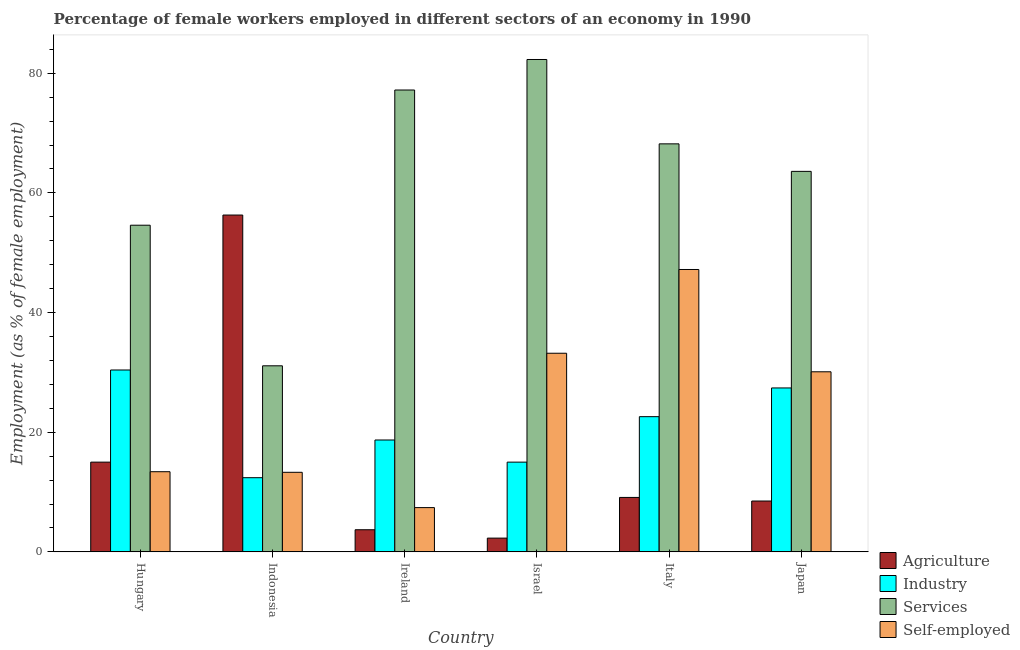How many different coloured bars are there?
Keep it short and to the point. 4. How many groups of bars are there?
Keep it short and to the point. 6. Are the number of bars per tick equal to the number of legend labels?
Your answer should be very brief. Yes. What is the label of the 1st group of bars from the left?
Offer a terse response. Hungary. In how many cases, is the number of bars for a given country not equal to the number of legend labels?
Your answer should be very brief. 0. Across all countries, what is the maximum percentage of female workers in agriculture?
Offer a terse response. 56.3. Across all countries, what is the minimum percentage of self employed female workers?
Make the answer very short. 7.4. In which country was the percentage of self employed female workers minimum?
Your answer should be compact. Ireland. What is the total percentage of female workers in industry in the graph?
Offer a terse response. 126.5. What is the difference between the percentage of female workers in agriculture in Israel and that in Japan?
Your answer should be very brief. -6.2. What is the difference between the percentage of female workers in agriculture in Israel and the percentage of female workers in industry in Indonesia?
Provide a succinct answer. -10.1. What is the average percentage of female workers in agriculture per country?
Your answer should be compact. 15.82. What is the difference between the percentage of female workers in industry and percentage of female workers in agriculture in Ireland?
Your answer should be very brief. 15. What is the ratio of the percentage of female workers in agriculture in Ireland to that in Italy?
Ensure brevity in your answer.  0.41. Is the percentage of female workers in agriculture in Hungary less than that in Israel?
Offer a very short reply. No. What is the difference between the highest and the second highest percentage of female workers in agriculture?
Your answer should be very brief. 41.3. What is the difference between the highest and the lowest percentage of female workers in agriculture?
Give a very brief answer. 54. In how many countries, is the percentage of female workers in agriculture greater than the average percentage of female workers in agriculture taken over all countries?
Provide a succinct answer. 1. Is it the case that in every country, the sum of the percentage of female workers in services and percentage of female workers in agriculture is greater than the sum of percentage of female workers in industry and percentage of self employed female workers?
Provide a succinct answer. No. What does the 4th bar from the left in Italy represents?
Your response must be concise. Self-employed. What does the 4th bar from the right in Japan represents?
Your answer should be very brief. Agriculture. Is it the case that in every country, the sum of the percentage of female workers in agriculture and percentage of female workers in industry is greater than the percentage of female workers in services?
Provide a succinct answer. No. Are all the bars in the graph horizontal?
Keep it short and to the point. No. Are the values on the major ticks of Y-axis written in scientific E-notation?
Ensure brevity in your answer.  No. Does the graph contain any zero values?
Offer a terse response. No. Does the graph contain grids?
Make the answer very short. No. How are the legend labels stacked?
Your answer should be compact. Vertical. What is the title of the graph?
Provide a short and direct response. Percentage of female workers employed in different sectors of an economy in 1990. What is the label or title of the Y-axis?
Offer a terse response. Employment (as % of female employment). What is the Employment (as % of female employment) of Industry in Hungary?
Provide a short and direct response. 30.4. What is the Employment (as % of female employment) of Services in Hungary?
Offer a terse response. 54.6. What is the Employment (as % of female employment) of Self-employed in Hungary?
Keep it short and to the point. 13.4. What is the Employment (as % of female employment) in Agriculture in Indonesia?
Keep it short and to the point. 56.3. What is the Employment (as % of female employment) in Industry in Indonesia?
Your response must be concise. 12.4. What is the Employment (as % of female employment) of Services in Indonesia?
Your response must be concise. 31.1. What is the Employment (as % of female employment) of Self-employed in Indonesia?
Provide a short and direct response. 13.3. What is the Employment (as % of female employment) in Agriculture in Ireland?
Ensure brevity in your answer.  3.7. What is the Employment (as % of female employment) in Industry in Ireland?
Your response must be concise. 18.7. What is the Employment (as % of female employment) of Services in Ireland?
Offer a terse response. 77.2. What is the Employment (as % of female employment) in Self-employed in Ireland?
Your response must be concise. 7.4. What is the Employment (as % of female employment) of Agriculture in Israel?
Offer a very short reply. 2.3. What is the Employment (as % of female employment) of Industry in Israel?
Keep it short and to the point. 15. What is the Employment (as % of female employment) of Services in Israel?
Your answer should be compact. 82.3. What is the Employment (as % of female employment) of Self-employed in Israel?
Offer a terse response. 33.2. What is the Employment (as % of female employment) of Agriculture in Italy?
Offer a terse response. 9.1. What is the Employment (as % of female employment) in Industry in Italy?
Provide a short and direct response. 22.6. What is the Employment (as % of female employment) of Services in Italy?
Your response must be concise. 68.2. What is the Employment (as % of female employment) of Self-employed in Italy?
Ensure brevity in your answer.  47.2. What is the Employment (as % of female employment) in Industry in Japan?
Offer a very short reply. 27.4. What is the Employment (as % of female employment) of Services in Japan?
Provide a succinct answer. 63.6. What is the Employment (as % of female employment) in Self-employed in Japan?
Provide a short and direct response. 30.1. Across all countries, what is the maximum Employment (as % of female employment) in Agriculture?
Give a very brief answer. 56.3. Across all countries, what is the maximum Employment (as % of female employment) of Industry?
Provide a short and direct response. 30.4. Across all countries, what is the maximum Employment (as % of female employment) in Services?
Keep it short and to the point. 82.3. Across all countries, what is the maximum Employment (as % of female employment) of Self-employed?
Provide a succinct answer. 47.2. Across all countries, what is the minimum Employment (as % of female employment) in Agriculture?
Provide a succinct answer. 2.3. Across all countries, what is the minimum Employment (as % of female employment) in Industry?
Offer a very short reply. 12.4. Across all countries, what is the minimum Employment (as % of female employment) in Services?
Make the answer very short. 31.1. Across all countries, what is the minimum Employment (as % of female employment) of Self-employed?
Make the answer very short. 7.4. What is the total Employment (as % of female employment) of Agriculture in the graph?
Provide a succinct answer. 94.9. What is the total Employment (as % of female employment) in Industry in the graph?
Offer a very short reply. 126.5. What is the total Employment (as % of female employment) in Services in the graph?
Give a very brief answer. 377. What is the total Employment (as % of female employment) in Self-employed in the graph?
Give a very brief answer. 144.6. What is the difference between the Employment (as % of female employment) of Agriculture in Hungary and that in Indonesia?
Keep it short and to the point. -41.3. What is the difference between the Employment (as % of female employment) of Industry in Hungary and that in Indonesia?
Your answer should be very brief. 18. What is the difference between the Employment (as % of female employment) in Services in Hungary and that in Indonesia?
Ensure brevity in your answer.  23.5. What is the difference between the Employment (as % of female employment) of Self-employed in Hungary and that in Indonesia?
Keep it short and to the point. 0.1. What is the difference between the Employment (as % of female employment) in Industry in Hungary and that in Ireland?
Your answer should be compact. 11.7. What is the difference between the Employment (as % of female employment) in Services in Hungary and that in Ireland?
Ensure brevity in your answer.  -22.6. What is the difference between the Employment (as % of female employment) of Self-employed in Hungary and that in Ireland?
Give a very brief answer. 6. What is the difference between the Employment (as % of female employment) of Industry in Hungary and that in Israel?
Provide a succinct answer. 15.4. What is the difference between the Employment (as % of female employment) of Services in Hungary and that in Israel?
Offer a terse response. -27.7. What is the difference between the Employment (as % of female employment) in Self-employed in Hungary and that in Israel?
Provide a short and direct response. -19.8. What is the difference between the Employment (as % of female employment) of Agriculture in Hungary and that in Italy?
Offer a terse response. 5.9. What is the difference between the Employment (as % of female employment) in Industry in Hungary and that in Italy?
Make the answer very short. 7.8. What is the difference between the Employment (as % of female employment) in Services in Hungary and that in Italy?
Your response must be concise. -13.6. What is the difference between the Employment (as % of female employment) of Self-employed in Hungary and that in Italy?
Make the answer very short. -33.8. What is the difference between the Employment (as % of female employment) in Agriculture in Hungary and that in Japan?
Provide a succinct answer. 6.5. What is the difference between the Employment (as % of female employment) of Industry in Hungary and that in Japan?
Give a very brief answer. 3. What is the difference between the Employment (as % of female employment) in Services in Hungary and that in Japan?
Provide a short and direct response. -9. What is the difference between the Employment (as % of female employment) in Self-employed in Hungary and that in Japan?
Offer a terse response. -16.7. What is the difference between the Employment (as % of female employment) of Agriculture in Indonesia and that in Ireland?
Offer a very short reply. 52.6. What is the difference between the Employment (as % of female employment) of Industry in Indonesia and that in Ireland?
Give a very brief answer. -6.3. What is the difference between the Employment (as % of female employment) in Services in Indonesia and that in Ireland?
Offer a terse response. -46.1. What is the difference between the Employment (as % of female employment) in Self-employed in Indonesia and that in Ireland?
Give a very brief answer. 5.9. What is the difference between the Employment (as % of female employment) in Services in Indonesia and that in Israel?
Provide a short and direct response. -51.2. What is the difference between the Employment (as % of female employment) of Self-employed in Indonesia and that in Israel?
Ensure brevity in your answer.  -19.9. What is the difference between the Employment (as % of female employment) of Agriculture in Indonesia and that in Italy?
Keep it short and to the point. 47.2. What is the difference between the Employment (as % of female employment) in Services in Indonesia and that in Italy?
Keep it short and to the point. -37.1. What is the difference between the Employment (as % of female employment) of Self-employed in Indonesia and that in Italy?
Your answer should be very brief. -33.9. What is the difference between the Employment (as % of female employment) in Agriculture in Indonesia and that in Japan?
Offer a terse response. 47.8. What is the difference between the Employment (as % of female employment) of Industry in Indonesia and that in Japan?
Provide a short and direct response. -15. What is the difference between the Employment (as % of female employment) of Services in Indonesia and that in Japan?
Provide a short and direct response. -32.5. What is the difference between the Employment (as % of female employment) of Self-employed in Indonesia and that in Japan?
Your response must be concise. -16.8. What is the difference between the Employment (as % of female employment) of Industry in Ireland and that in Israel?
Make the answer very short. 3.7. What is the difference between the Employment (as % of female employment) of Services in Ireland and that in Israel?
Provide a short and direct response. -5.1. What is the difference between the Employment (as % of female employment) in Self-employed in Ireland and that in Israel?
Keep it short and to the point. -25.8. What is the difference between the Employment (as % of female employment) in Industry in Ireland and that in Italy?
Give a very brief answer. -3.9. What is the difference between the Employment (as % of female employment) in Self-employed in Ireland and that in Italy?
Offer a very short reply. -39.8. What is the difference between the Employment (as % of female employment) in Services in Ireland and that in Japan?
Provide a short and direct response. 13.6. What is the difference between the Employment (as % of female employment) of Self-employed in Ireland and that in Japan?
Your response must be concise. -22.7. What is the difference between the Employment (as % of female employment) in Industry in Israel and that in Italy?
Offer a very short reply. -7.6. What is the difference between the Employment (as % of female employment) of Services in Israel and that in Italy?
Keep it short and to the point. 14.1. What is the difference between the Employment (as % of female employment) in Agriculture in Israel and that in Japan?
Your answer should be very brief. -6.2. What is the difference between the Employment (as % of female employment) in Self-employed in Israel and that in Japan?
Keep it short and to the point. 3.1. What is the difference between the Employment (as % of female employment) of Agriculture in Italy and that in Japan?
Provide a short and direct response. 0.6. What is the difference between the Employment (as % of female employment) of Services in Italy and that in Japan?
Your answer should be very brief. 4.6. What is the difference between the Employment (as % of female employment) in Agriculture in Hungary and the Employment (as % of female employment) in Industry in Indonesia?
Provide a succinct answer. 2.6. What is the difference between the Employment (as % of female employment) in Agriculture in Hungary and the Employment (as % of female employment) in Services in Indonesia?
Provide a short and direct response. -16.1. What is the difference between the Employment (as % of female employment) of Industry in Hungary and the Employment (as % of female employment) of Services in Indonesia?
Offer a terse response. -0.7. What is the difference between the Employment (as % of female employment) in Services in Hungary and the Employment (as % of female employment) in Self-employed in Indonesia?
Offer a terse response. 41.3. What is the difference between the Employment (as % of female employment) in Agriculture in Hungary and the Employment (as % of female employment) in Services in Ireland?
Provide a succinct answer. -62.2. What is the difference between the Employment (as % of female employment) of Industry in Hungary and the Employment (as % of female employment) of Services in Ireland?
Offer a terse response. -46.8. What is the difference between the Employment (as % of female employment) of Industry in Hungary and the Employment (as % of female employment) of Self-employed in Ireland?
Your response must be concise. 23. What is the difference between the Employment (as % of female employment) of Services in Hungary and the Employment (as % of female employment) of Self-employed in Ireland?
Offer a terse response. 47.2. What is the difference between the Employment (as % of female employment) of Agriculture in Hungary and the Employment (as % of female employment) of Industry in Israel?
Offer a terse response. 0. What is the difference between the Employment (as % of female employment) in Agriculture in Hungary and the Employment (as % of female employment) in Services in Israel?
Your answer should be compact. -67.3. What is the difference between the Employment (as % of female employment) in Agriculture in Hungary and the Employment (as % of female employment) in Self-employed in Israel?
Your answer should be very brief. -18.2. What is the difference between the Employment (as % of female employment) in Industry in Hungary and the Employment (as % of female employment) in Services in Israel?
Make the answer very short. -51.9. What is the difference between the Employment (as % of female employment) in Services in Hungary and the Employment (as % of female employment) in Self-employed in Israel?
Ensure brevity in your answer.  21.4. What is the difference between the Employment (as % of female employment) in Agriculture in Hungary and the Employment (as % of female employment) in Industry in Italy?
Provide a succinct answer. -7.6. What is the difference between the Employment (as % of female employment) of Agriculture in Hungary and the Employment (as % of female employment) of Services in Italy?
Offer a terse response. -53.2. What is the difference between the Employment (as % of female employment) in Agriculture in Hungary and the Employment (as % of female employment) in Self-employed in Italy?
Your answer should be very brief. -32.2. What is the difference between the Employment (as % of female employment) of Industry in Hungary and the Employment (as % of female employment) of Services in Italy?
Make the answer very short. -37.8. What is the difference between the Employment (as % of female employment) in Industry in Hungary and the Employment (as % of female employment) in Self-employed in Italy?
Your response must be concise. -16.8. What is the difference between the Employment (as % of female employment) in Agriculture in Hungary and the Employment (as % of female employment) in Services in Japan?
Give a very brief answer. -48.6. What is the difference between the Employment (as % of female employment) of Agriculture in Hungary and the Employment (as % of female employment) of Self-employed in Japan?
Ensure brevity in your answer.  -15.1. What is the difference between the Employment (as % of female employment) in Industry in Hungary and the Employment (as % of female employment) in Services in Japan?
Provide a succinct answer. -33.2. What is the difference between the Employment (as % of female employment) of Services in Hungary and the Employment (as % of female employment) of Self-employed in Japan?
Provide a short and direct response. 24.5. What is the difference between the Employment (as % of female employment) of Agriculture in Indonesia and the Employment (as % of female employment) of Industry in Ireland?
Make the answer very short. 37.6. What is the difference between the Employment (as % of female employment) of Agriculture in Indonesia and the Employment (as % of female employment) of Services in Ireland?
Provide a succinct answer. -20.9. What is the difference between the Employment (as % of female employment) of Agriculture in Indonesia and the Employment (as % of female employment) of Self-employed in Ireland?
Offer a very short reply. 48.9. What is the difference between the Employment (as % of female employment) of Industry in Indonesia and the Employment (as % of female employment) of Services in Ireland?
Provide a succinct answer. -64.8. What is the difference between the Employment (as % of female employment) of Industry in Indonesia and the Employment (as % of female employment) of Self-employed in Ireland?
Offer a very short reply. 5. What is the difference between the Employment (as % of female employment) in Services in Indonesia and the Employment (as % of female employment) in Self-employed in Ireland?
Keep it short and to the point. 23.7. What is the difference between the Employment (as % of female employment) of Agriculture in Indonesia and the Employment (as % of female employment) of Industry in Israel?
Ensure brevity in your answer.  41.3. What is the difference between the Employment (as % of female employment) in Agriculture in Indonesia and the Employment (as % of female employment) in Services in Israel?
Keep it short and to the point. -26. What is the difference between the Employment (as % of female employment) of Agriculture in Indonesia and the Employment (as % of female employment) of Self-employed in Israel?
Make the answer very short. 23.1. What is the difference between the Employment (as % of female employment) in Industry in Indonesia and the Employment (as % of female employment) in Services in Israel?
Make the answer very short. -69.9. What is the difference between the Employment (as % of female employment) of Industry in Indonesia and the Employment (as % of female employment) of Self-employed in Israel?
Offer a terse response. -20.8. What is the difference between the Employment (as % of female employment) of Services in Indonesia and the Employment (as % of female employment) of Self-employed in Israel?
Offer a very short reply. -2.1. What is the difference between the Employment (as % of female employment) in Agriculture in Indonesia and the Employment (as % of female employment) in Industry in Italy?
Your answer should be very brief. 33.7. What is the difference between the Employment (as % of female employment) in Industry in Indonesia and the Employment (as % of female employment) in Services in Italy?
Make the answer very short. -55.8. What is the difference between the Employment (as % of female employment) in Industry in Indonesia and the Employment (as % of female employment) in Self-employed in Italy?
Your answer should be very brief. -34.8. What is the difference between the Employment (as % of female employment) of Services in Indonesia and the Employment (as % of female employment) of Self-employed in Italy?
Your answer should be compact. -16.1. What is the difference between the Employment (as % of female employment) in Agriculture in Indonesia and the Employment (as % of female employment) in Industry in Japan?
Provide a short and direct response. 28.9. What is the difference between the Employment (as % of female employment) of Agriculture in Indonesia and the Employment (as % of female employment) of Services in Japan?
Your answer should be very brief. -7.3. What is the difference between the Employment (as % of female employment) in Agriculture in Indonesia and the Employment (as % of female employment) in Self-employed in Japan?
Your answer should be very brief. 26.2. What is the difference between the Employment (as % of female employment) of Industry in Indonesia and the Employment (as % of female employment) of Services in Japan?
Offer a very short reply. -51.2. What is the difference between the Employment (as % of female employment) of Industry in Indonesia and the Employment (as % of female employment) of Self-employed in Japan?
Make the answer very short. -17.7. What is the difference between the Employment (as % of female employment) of Services in Indonesia and the Employment (as % of female employment) of Self-employed in Japan?
Make the answer very short. 1. What is the difference between the Employment (as % of female employment) in Agriculture in Ireland and the Employment (as % of female employment) in Industry in Israel?
Your answer should be very brief. -11.3. What is the difference between the Employment (as % of female employment) in Agriculture in Ireland and the Employment (as % of female employment) in Services in Israel?
Your answer should be compact. -78.6. What is the difference between the Employment (as % of female employment) of Agriculture in Ireland and the Employment (as % of female employment) of Self-employed in Israel?
Give a very brief answer. -29.5. What is the difference between the Employment (as % of female employment) of Industry in Ireland and the Employment (as % of female employment) of Services in Israel?
Give a very brief answer. -63.6. What is the difference between the Employment (as % of female employment) in Industry in Ireland and the Employment (as % of female employment) in Self-employed in Israel?
Make the answer very short. -14.5. What is the difference between the Employment (as % of female employment) of Agriculture in Ireland and the Employment (as % of female employment) of Industry in Italy?
Offer a terse response. -18.9. What is the difference between the Employment (as % of female employment) of Agriculture in Ireland and the Employment (as % of female employment) of Services in Italy?
Offer a terse response. -64.5. What is the difference between the Employment (as % of female employment) of Agriculture in Ireland and the Employment (as % of female employment) of Self-employed in Italy?
Provide a succinct answer. -43.5. What is the difference between the Employment (as % of female employment) of Industry in Ireland and the Employment (as % of female employment) of Services in Italy?
Your answer should be very brief. -49.5. What is the difference between the Employment (as % of female employment) of Industry in Ireland and the Employment (as % of female employment) of Self-employed in Italy?
Your answer should be very brief. -28.5. What is the difference between the Employment (as % of female employment) of Agriculture in Ireland and the Employment (as % of female employment) of Industry in Japan?
Your response must be concise. -23.7. What is the difference between the Employment (as % of female employment) of Agriculture in Ireland and the Employment (as % of female employment) of Services in Japan?
Offer a terse response. -59.9. What is the difference between the Employment (as % of female employment) in Agriculture in Ireland and the Employment (as % of female employment) in Self-employed in Japan?
Ensure brevity in your answer.  -26.4. What is the difference between the Employment (as % of female employment) of Industry in Ireland and the Employment (as % of female employment) of Services in Japan?
Keep it short and to the point. -44.9. What is the difference between the Employment (as % of female employment) in Services in Ireland and the Employment (as % of female employment) in Self-employed in Japan?
Provide a succinct answer. 47.1. What is the difference between the Employment (as % of female employment) in Agriculture in Israel and the Employment (as % of female employment) in Industry in Italy?
Your answer should be compact. -20.3. What is the difference between the Employment (as % of female employment) in Agriculture in Israel and the Employment (as % of female employment) in Services in Italy?
Provide a short and direct response. -65.9. What is the difference between the Employment (as % of female employment) in Agriculture in Israel and the Employment (as % of female employment) in Self-employed in Italy?
Ensure brevity in your answer.  -44.9. What is the difference between the Employment (as % of female employment) of Industry in Israel and the Employment (as % of female employment) of Services in Italy?
Give a very brief answer. -53.2. What is the difference between the Employment (as % of female employment) of Industry in Israel and the Employment (as % of female employment) of Self-employed in Italy?
Offer a terse response. -32.2. What is the difference between the Employment (as % of female employment) in Services in Israel and the Employment (as % of female employment) in Self-employed in Italy?
Provide a succinct answer. 35.1. What is the difference between the Employment (as % of female employment) in Agriculture in Israel and the Employment (as % of female employment) in Industry in Japan?
Offer a terse response. -25.1. What is the difference between the Employment (as % of female employment) in Agriculture in Israel and the Employment (as % of female employment) in Services in Japan?
Offer a terse response. -61.3. What is the difference between the Employment (as % of female employment) of Agriculture in Israel and the Employment (as % of female employment) of Self-employed in Japan?
Provide a short and direct response. -27.8. What is the difference between the Employment (as % of female employment) in Industry in Israel and the Employment (as % of female employment) in Services in Japan?
Offer a terse response. -48.6. What is the difference between the Employment (as % of female employment) of Industry in Israel and the Employment (as % of female employment) of Self-employed in Japan?
Your answer should be compact. -15.1. What is the difference between the Employment (as % of female employment) of Services in Israel and the Employment (as % of female employment) of Self-employed in Japan?
Ensure brevity in your answer.  52.2. What is the difference between the Employment (as % of female employment) in Agriculture in Italy and the Employment (as % of female employment) in Industry in Japan?
Give a very brief answer. -18.3. What is the difference between the Employment (as % of female employment) in Agriculture in Italy and the Employment (as % of female employment) in Services in Japan?
Make the answer very short. -54.5. What is the difference between the Employment (as % of female employment) in Agriculture in Italy and the Employment (as % of female employment) in Self-employed in Japan?
Offer a terse response. -21. What is the difference between the Employment (as % of female employment) of Industry in Italy and the Employment (as % of female employment) of Services in Japan?
Give a very brief answer. -41. What is the difference between the Employment (as % of female employment) in Services in Italy and the Employment (as % of female employment) in Self-employed in Japan?
Ensure brevity in your answer.  38.1. What is the average Employment (as % of female employment) in Agriculture per country?
Make the answer very short. 15.82. What is the average Employment (as % of female employment) in Industry per country?
Make the answer very short. 21.08. What is the average Employment (as % of female employment) of Services per country?
Provide a short and direct response. 62.83. What is the average Employment (as % of female employment) of Self-employed per country?
Offer a very short reply. 24.1. What is the difference between the Employment (as % of female employment) in Agriculture and Employment (as % of female employment) in Industry in Hungary?
Offer a terse response. -15.4. What is the difference between the Employment (as % of female employment) in Agriculture and Employment (as % of female employment) in Services in Hungary?
Your answer should be compact. -39.6. What is the difference between the Employment (as % of female employment) in Industry and Employment (as % of female employment) in Services in Hungary?
Provide a short and direct response. -24.2. What is the difference between the Employment (as % of female employment) of Industry and Employment (as % of female employment) of Self-employed in Hungary?
Ensure brevity in your answer.  17. What is the difference between the Employment (as % of female employment) in Services and Employment (as % of female employment) in Self-employed in Hungary?
Your response must be concise. 41.2. What is the difference between the Employment (as % of female employment) of Agriculture and Employment (as % of female employment) of Industry in Indonesia?
Your response must be concise. 43.9. What is the difference between the Employment (as % of female employment) in Agriculture and Employment (as % of female employment) in Services in Indonesia?
Make the answer very short. 25.2. What is the difference between the Employment (as % of female employment) of Industry and Employment (as % of female employment) of Services in Indonesia?
Give a very brief answer. -18.7. What is the difference between the Employment (as % of female employment) of Industry and Employment (as % of female employment) of Self-employed in Indonesia?
Your answer should be compact. -0.9. What is the difference between the Employment (as % of female employment) of Agriculture and Employment (as % of female employment) of Services in Ireland?
Offer a very short reply. -73.5. What is the difference between the Employment (as % of female employment) of Agriculture and Employment (as % of female employment) of Self-employed in Ireland?
Make the answer very short. -3.7. What is the difference between the Employment (as % of female employment) in Industry and Employment (as % of female employment) in Services in Ireland?
Make the answer very short. -58.5. What is the difference between the Employment (as % of female employment) of Services and Employment (as % of female employment) of Self-employed in Ireland?
Provide a short and direct response. 69.8. What is the difference between the Employment (as % of female employment) of Agriculture and Employment (as % of female employment) of Industry in Israel?
Offer a very short reply. -12.7. What is the difference between the Employment (as % of female employment) of Agriculture and Employment (as % of female employment) of Services in Israel?
Offer a terse response. -80. What is the difference between the Employment (as % of female employment) of Agriculture and Employment (as % of female employment) of Self-employed in Israel?
Your answer should be very brief. -30.9. What is the difference between the Employment (as % of female employment) in Industry and Employment (as % of female employment) in Services in Israel?
Offer a very short reply. -67.3. What is the difference between the Employment (as % of female employment) in Industry and Employment (as % of female employment) in Self-employed in Israel?
Ensure brevity in your answer.  -18.2. What is the difference between the Employment (as % of female employment) in Services and Employment (as % of female employment) in Self-employed in Israel?
Offer a terse response. 49.1. What is the difference between the Employment (as % of female employment) in Agriculture and Employment (as % of female employment) in Industry in Italy?
Ensure brevity in your answer.  -13.5. What is the difference between the Employment (as % of female employment) of Agriculture and Employment (as % of female employment) of Services in Italy?
Provide a succinct answer. -59.1. What is the difference between the Employment (as % of female employment) of Agriculture and Employment (as % of female employment) of Self-employed in Italy?
Offer a terse response. -38.1. What is the difference between the Employment (as % of female employment) of Industry and Employment (as % of female employment) of Services in Italy?
Your answer should be very brief. -45.6. What is the difference between the Employment (as % of female employment) of Industry and Employment (as % of female employment) of Self-employed in Italy?
Provide a succinct answer. -24.6. What is the difference between the Employment (as % of female employment) of Services and Employment (as % of female employment) of Self-employed in Italy?
Ensure brevity in your answer.  21. What is the difference between the Employment (as % of female employment) in Agriculture and Employment (as % of female employment) in Industry in Japan?
Give a very brief answer. -18.9. What is the difference between the Employment (as % of female employment) of Agriculture and Employment (as % of female employment) of Services in Japan?
Offer a very short reply. -55.1. What is the difference between the Employment (as % of female employment) in Agriculture and Employment (as % of female employment) in Self-employed in Japan?
Your answer should be very brief. -21.6. What is the difference between the Employment (as % of female employment) of Industry and Employment (as % of female employment) of Services in Japan?
Give a very brief answer. -36.2. What is the difference between the Employment (as % of female employment) of Industry and Employment (as % of female employment) of Self-employed in Japan?
Give a very brief answer. -2.7. What is the difference between the Employment (as % of female employment) of Services and Employment (as % of female employment) of Self-employed in Japan?
Make the answer very short. 33.5. What is the ratio of the Employment (as % of female employment) of Agriculture in Hungary to that in Indonesia?
Provide a short and direct response. 0.27. What is the ratio of the Employment (as % of female employment) in Industry in Hungary to that in Indonesia?
Keep it short and to the point. 2.45. What is the ratio of the Employment (as % of female employment) in Services in Hungary to that in Indonesia?
Your answer should be compact. 1.76. What is the ratio of the Employment (as % of female employment) in Self-employed in Hungary to that in Indonesia?
Your answer should be compact. 1.01. What is the ratio of the Employment (as % of female employment) of Agriculture in Hungary to that in Ireland?
Your response must be concise. 4.05. What is the ratio of the Employment (as % of female employment) in Industry in Hungary to that in Ireland?
Offer a terse response. 1.63. What is the ratio of the Employment (as % of female employment) of Services in Hungary to that in Ireland?
Provide a succinct answer. 0.71. What is the ratio of the Employment (as % of female employment) in Self-employed in Hungary to that in Ireland?
Your answer should be very brief. 1.81. What is the ratio of the Employment (as % of female employment) in Agriculture in Hungary to that in Israel?
Your answer should be compact. 6.52. What is the ratio of the Employment (as % of female employment) in Industry in Hungary to that in Israel?
Provide a succinct answer. 2.03. What is the ratio of the Employment (as % of female employment) in Services in Hungary to that in Israel?
Give a very brief answer. 0.66. What is the ratio of the Employment (as % of female employment) of Self-employed in Hungary to that in Israel?
Make the answer very short. 0.4. What is the ratio of the Employment (as % of female employment) in Agriculture in Hungary to that in Italy?
Offer a very short reply. 1.65. What is the ratio of the Employment (as % of female employment) of Industry in Hungary to that in Italy?
Provide a succinct answer. 1.35. What is the ratio of the Employment (as % of female employment) in Services in Hungary to that in Italy?
Offer a terse response. 0.8. What is the ratio of the Employment (as % of female employment) in Self-employed in Hungary to that in Italy?
Provide a succinct answer. 0.28. What is the ratio of the Employment (as % of female employment) of Agriculture in Hungary to that in Japan?
Offer a very short reply. 1.76. What is the ratio of the Employment (as % of female employment) in Industry in Hungary to that in Japan?
Your response must be concise. 1.11. What is the ratio of the Employment (as % of female employment) in Services in Hungary to that in Japan?
Offer a terse response. 0.86. What is the ratio of the Employment (as % of female employment) in Self-employed in Hungary to that in Japan?
Ensure brevity in your answer.  0.45. What is the ratio of the Employment (as % of female employment) of Agriculture in Indonesia to that in Ireland?
Provide a succinct answer. 15.22. What is the ratio of the Employment (as % of female employment) in Industry in Indonesia to that in Ireland?
Your answer should be very brief. 0.66. What is the ratio of the Employment (as % of female employment) in Services in Indonesia to that in Ireland?
Provide a succinct answer. 0.4. What is the ratio of the Employment (as % of female employment) of Self-employed in Indonesia to that in Ireland?
Provide a succinct answer. 1.8. What is the ratio of the Employment (as % of female employment) of Agriculture in Indonesia to that in Israel?
Offer a very short reply. 24.48. What is the ratio of the Employment (as % of female employment) in Industry in Indonesia to that in Israel?
Ensure brevity in your answer.  0.83. What is the ratio of the Employment (as % of female employment) of Services in Indonesia to that in Israel?
Make the answer very short. 0.38. What is the ratio of the Employment (as % of female employment) in Self-employed in Indonesia to that in Israel?
Offer a terse response. 0.4. What is the ratio of the Employment (as % of female employment) in Agriculture in Indonesia to that in Italy?
Offer a terse response. 6.19. What is the ratio of the Employment (as % of female employment) in Industry in Indonesia to that in Italy?
Offer a terse response. 0.55. What is the ratio of the Employment (as % of female employment) in Services in Indonesia to that in Italy?
Offer a terse response. 0.46. What is the ratio of the Employment (as % of female employment) in Self-employed in Indonesia to that in Italy?
Your answer should be very brief. 0.28. What is the ratio of the Employment (as % of female employment) in Agriculture in Indonesia to that in Japan?
Keep it short and to the point. 6.62. What is the ratio of the Employment (as % of female employment) in Industry in Indonesia to that in Japan?
Ensure brevity in your answer.  0.45. What is the ratio of the Employment (as % of female employment) in Services in Indonesia to that in Japan?
Offer a terse response. 0.49. What is the ratio of the Employment (as % of female employment) in Self-employed in Indonesia to that in Japan?
Offer a very short reply. 0.44. What is the ratio of the Employment (as % of female employment) in Agriculture in Ireland to that in Israel?
Your answer should be very brief. 1.61. What is the ratio of the Employment (as % of female employment) in Industry in Ireland to that in Israel?
Your answer should be compact. 1.25. What is the ratio of the Employment (as % of female employment) in Services in Ireland to that in Israel?
Make the answer very short. 0.94. What is the ratio of the Employment (as % of female employment) in Self-employed in Ireland to that in Israel?
Your answer should be compact. 0.22. What is the ratio of the Employment (as % of female employment) of Agriculture in Ireland to that in Italy?
Your answer should be very brief. 0.41. What is the ratio of the Employment (as % of female employment) in Industry in Ireland to that in Italy?
Your answer should be very brief. 0.83. What is the ratio of the Employment (as % of female employment) of Services in Ireland to that in Italy?
Make the answer very short. 1.13. What is the ratio of the Employment (as % of female employment) in Self-employed in Ireland to that in Italy?
Your response must be concise. 0.16. What is the ratio of the Employment (as % of female employment) in Agriculture in Ireland to that in Japan?
Offer a terse response. 0.44. What is the ratio of the Employment (as % of female employment) of Industry in Ireland to that in Japan?
Your answer should be compact. 0.68. What is the ratio of the Employment (as % of female employment) of Services in Ireland to that in Japan?
Provide a succinct answer. 1.21. What is the ratio of the Employment (as % of female employment) of Self-employed in Ireland to that in Japan?
Provide a short and direct response. 0.25. What is the ratio of the Employment (as % of female employment) of Agriculture in Israel to that in Italy?
Your answer should be very brief. 0.25. What is the ratio of the Employment (as % of female employment) in Industry in Israel to that in Italy?
Provide a succinct answer. 0.66. What is the ratio of the Employment (as % of female employment) in Services in Israel to that in Italy?
Offer a terse response. 1.21. What is the ratio of the Employment (as % of female employment) in Self-employed in Israel to that in Italy?
Your response must be concise. 0.7. What is the ratio of the Employment (as % of female employment) in Agriculture in Israel to that in Japan?
Provide a succinct answer. 0.27. What is the ratio of the Employment (as % of female employment) in Industry in Israel to that in Japan?
Ensure brevity in your answer.  0.55. What is the ratio of the Employment (as % of female employment) of Services in Israel to that in Japan?
Offer a very short reply. 1.29. What is the ratio of the Employment (as % of female employment) in Self-employed in Israel to that in Japan?
Offer a terse response. 1.1. What is the ratio of the Employment (as % of female employment) of Agriculture in Italy to that in Japan?
Provide a short and direct response. 1.07. What is the ratio of the Employment (as % of female employment) in Industry in Italy to that in Japan?
Give a very brief answer. 0.82. What is the ratio of the Employment (as % of female employment) of Services in Italy to that in Japan?
Offer a very short reply. 1.07. What is the ratio of the Employment (as % of female employment) in Self-employed in Italy to that in Japan?
Offer a terse response. 1.57. What is the difference between the highest and the second highest Employment (as % of female employment) in Agriculture?
Your answer should be compact. 41.3. What is the difference between the highest and the second highest Employment (as % of female employment) in Self-employed?
Your answer should be compact. 14. What is the difference between the highest and the lowest Employment (as % of female employment) of Agriculture?
Your answer should be compact. 54. What is the difference between the highest and the lowest Employment (as % of female employment) in Industry?
Your response must be concise. 18. What is the difference between the highest and the lowest Employment (as % of female employment) in Services?
Provide a succinct answer. 51.2. What is the difference between the highest and the lowest Employment (as % of female employment) in Self-employed?
Provide a short and direct response. 39.8. 